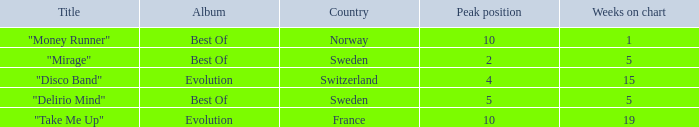What is the weeks on chart for the single from france? 19.0. 